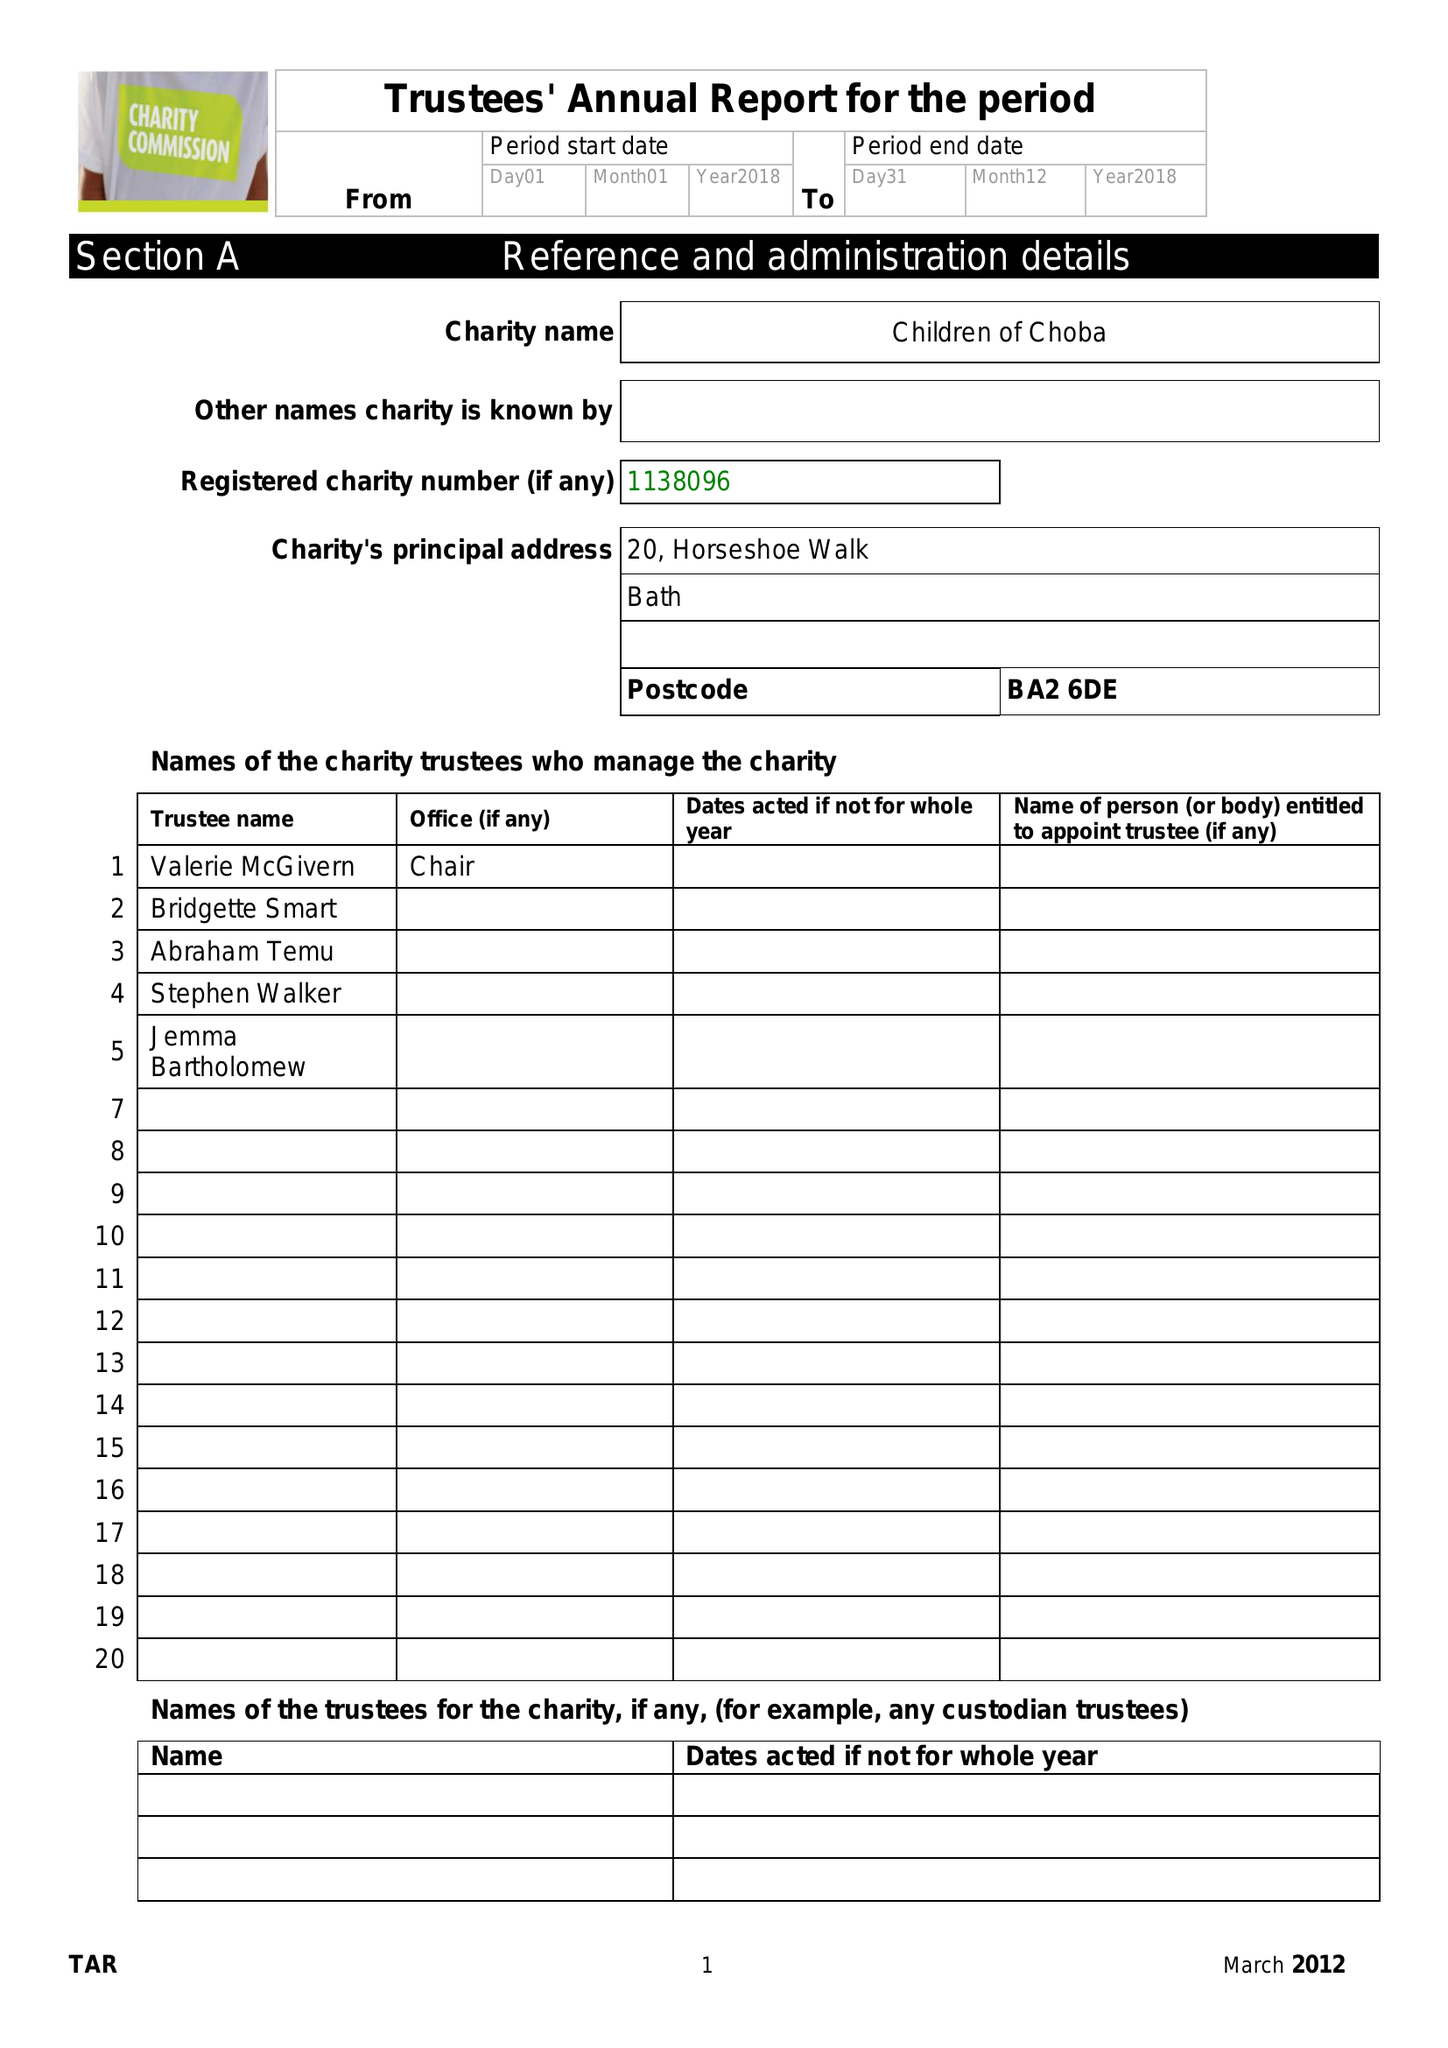What is the value for the address__post_town?
Answer the question using a single word or phrase. BATH 